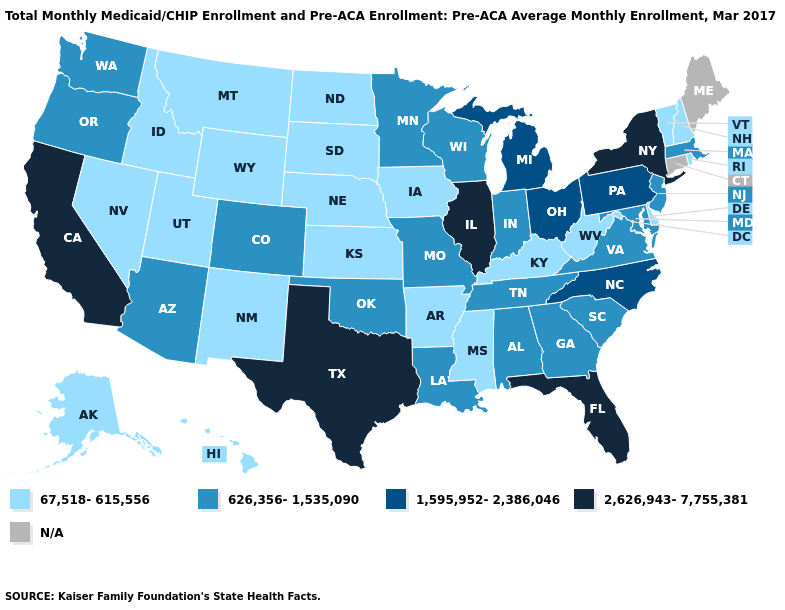Name the states that have a value in the range 2,626,943-7,755,381?
Write a very short answer. California, Florida, Illinois, New York, Texas. Among the states that border Georgia , which have the lowest value?
Short answer required. Alabama, South Carolina, Tennessee. Among the states that border Utah , does Colorado have the highest value?
Keep it brief. Yes. What is the value of Washington?
Keep it brief. 626,356-1,535,090. What is the lowest value in the USA?
Give a very brief answer. 67,518-615,556. Among the states that border West Virginia , which have the highest value?
Short answer required. Ohio, Pennsylvania. Does California have the highest value in the USA?
Concise answer only. Yes. What is the value of Nevada?
Quick response, please. 67,518-615,556. Which states hav the highest value in the West?
Give a very brief answer. California. What is the value of Alaska?
Keep it brief. 67,518-615,556. Name the states that have a value in the range 626,356-1,535,090?
Write a very short answer. Alabama, Arizona, Colorado, Georgia, Indiana, Louisiana, Maryland, Massachusetts, Minnesota, Missouri, New Jersey, Oklahoma, Oregon, South Carolina, Tennessee, Virginia, Washington, Wisconsin. What is the value of Nevada?
Write a very short answer. 67,518-615,556. 